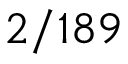Convert formula to latex. <formula><loc_0><loc_0><loc_500><loc_500>2 / 1 8 9</formula> 